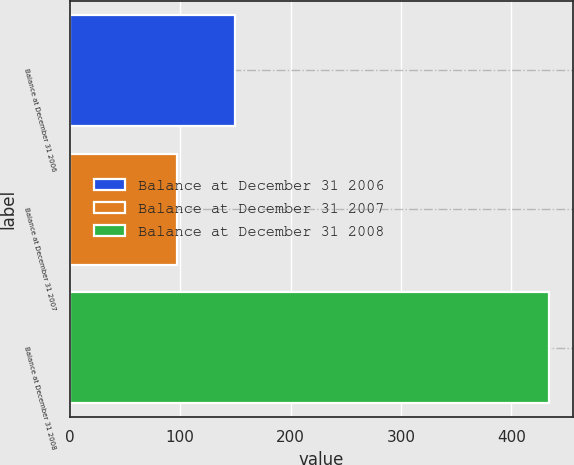Convert chart to OTSL. <chart><loc_0><loc_0><loc_500><loc_500><bar_chart><fcel>Balance at December 31 2006<fcel>Balance at December 31 2007<fcel>Balance at December 31 2008<nl><fcel>150<fcel>97<fcel>434<nl></chart> 